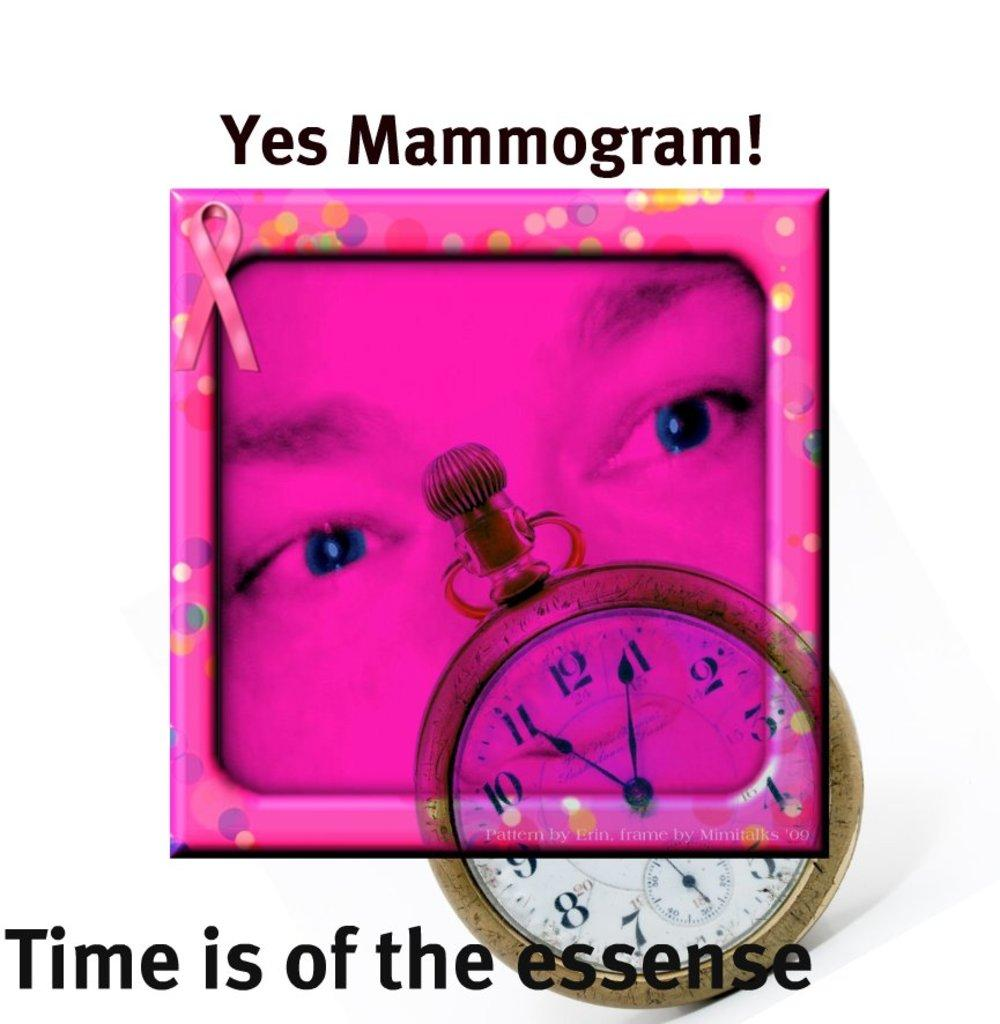<image>
Write a terse but informative summary of the picture. A purple square with a face on it , with it says "Yes mammogram!" above it. 